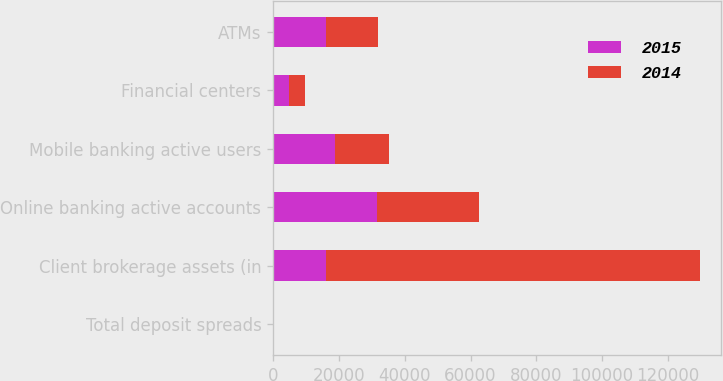<chart> <loc_0><loc_0><loc_500><loc_500><stacked_bar_chart><ecel><fcel>Total deposit spreads<fcel>Client brokerage assets (in<fcel>Online banking active accounts<fcel>Mobile banking active users<fcel>Financial centers<fcel>ATMs<nl><fcel>2015<fcel>1.63<fcel>16038<fcel>31674<fcel>18705<fcel>4726<fcel>16038<nl><fcel>2014<fcel>1.6<fcel>113763<fcel>30904<fcel>16539<fcel>4855<fcel>15834<nl></chart> 